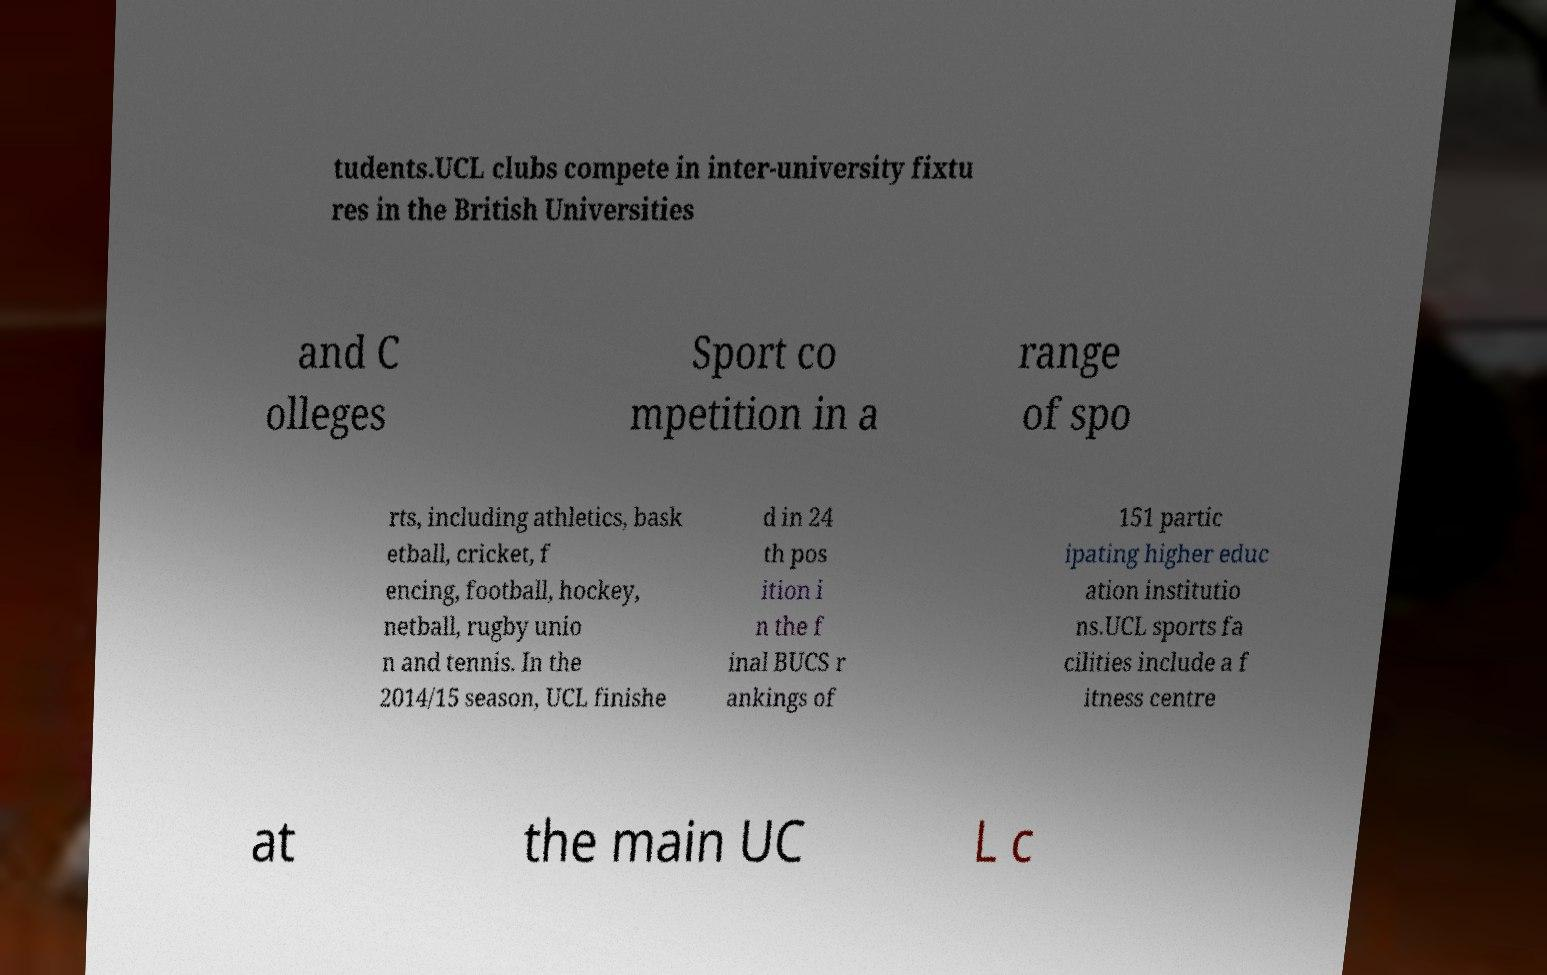What messages or text are displayed in this image? I need them in a readable, typed format. tudents.UCL clubs compete in inter-university fixtu res in the British Universities and C olleges Sport co mpetition in a range of spo rts, including athletics, bask etball, cricket, f encing, football, hockey, netball, rugby unio n and tennis. In the 2014/15 season, UCL finishe d in 24 th pos ition i n the f inal BUCS r ankings of 151 partic ipating higher educ ation institutio ns.UCL sports fa cilities include a f itness centre at the main UC L c 